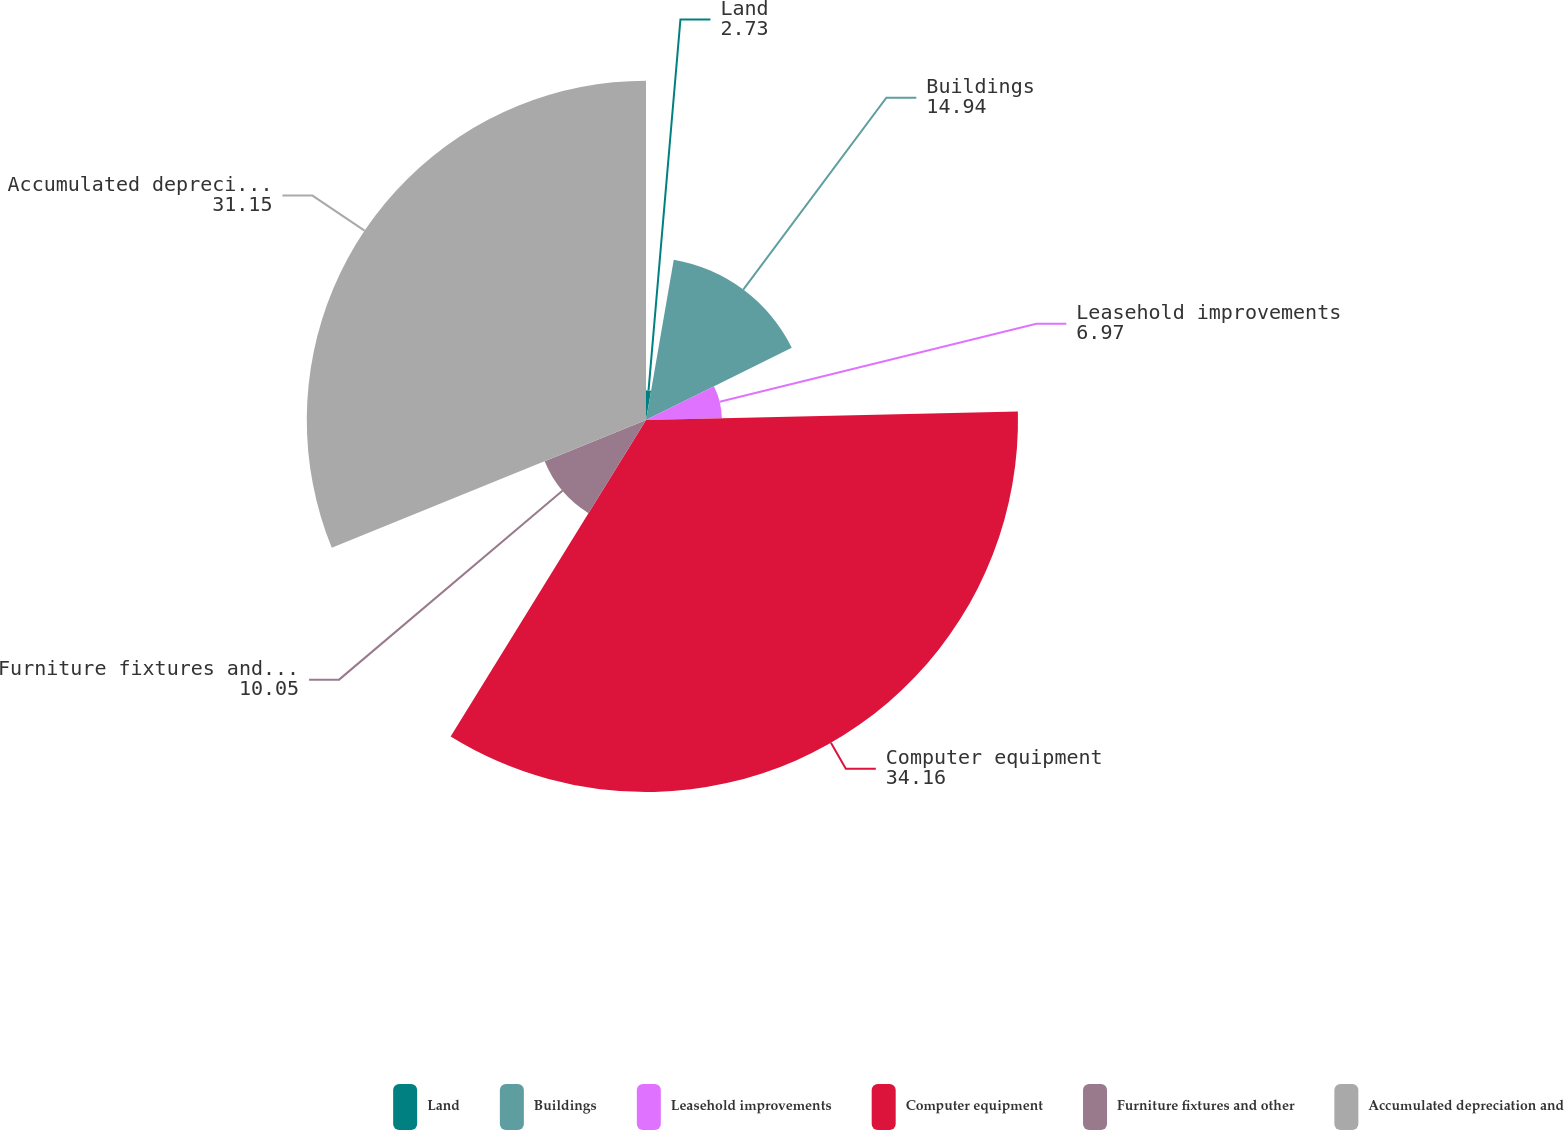Convert chart to OTSL. <chart><loc_0><loc_0><loc_500><loc_500><pie_chart><fcel>Land<fcel>Buildings<fcel>Leasehold improvements<fcel>Computer equipment<fcel>Furniture fixtures and other<fcel>Accumulated depreciation and<nl><fcel>2.73%<fcel>14.94%<fcel>6.97%<fcel>34.16%<fcel>10.05%<fcel>31.15%<nl></chart> 